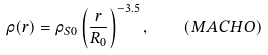Convert formula to latex. <formula><loc_0><loc_0><loc_500><loc_500>\rho ( r ) = \rho _ { S 0 } \left ( \frac { r } { R _ { 0 } } \right ) ^ { - 3 . 5 } , \quad ( M A C H O )</formula> 